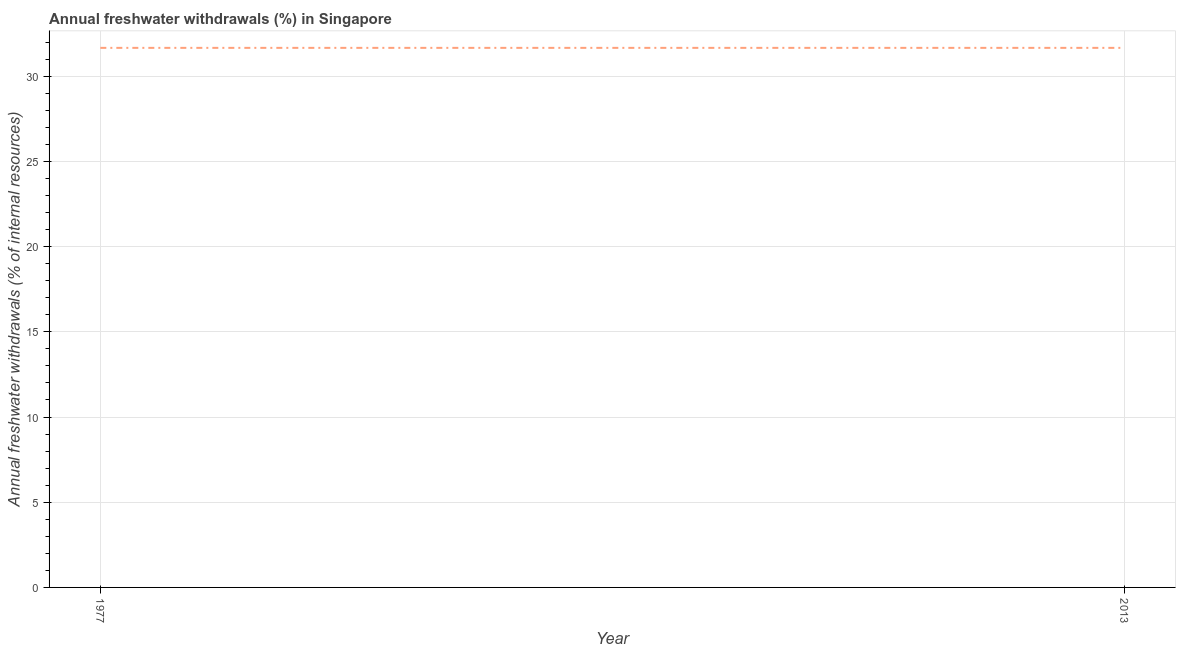What is the annual freshwater withdrawals in 2013?
Your answer should be compact. 31.67. Across all years, what is the maximum annual freshwater withdrawals?
Offer a terse response. 31.67. Across all years, what is the minimum annual freshwater withdrawals?
Provide a succinct answer. 31.67. In which year was the annual freshwater withdrawals minimum?
Offer a terse response. 1977. What is the sum of the annual freshwater withdrawals?
Your answer should be compact. 63.33. What is the average annual freshwater withdrawals per year?
Make the answer very short. 31.67. What is the median annual freshwater withdrawals?
Keep it short and to the point. 31.67. Is the annual freshwater withdrawals in 1977 less than that in 2013?
Ensure brevity in your answer.  No. Does the annual freshwater withdrawals monotonically increase over the years?
Your response must be concise. No. How many years are there in the graph?
Provide a short and direct response. 2. What is the difference between two consecutive major ticks on the Y-axis?
Make the answer very short. 5. Are the values on the major ticks of Y-axis written in scientific E-notation?
Your answer should be very brief. No. What is the title of the graph?
Your answer should be compact. Annual freshwater withdrawals (%) in Singapore. What is the label or title of the X-axis?
Offer a very short reply. Year. What is the label or title of the Y-axis?
Offer a terse response. Annual freshwater withdrawals (% of internal resources). What is the Annual freshwater withdrawals (% of internal resources) of 1977?
Keep it short and to the point. 31.67. What is the Annual freshwater withdrawals (% of internal resources) of 2013?
Your response must be concise. 31.67. 